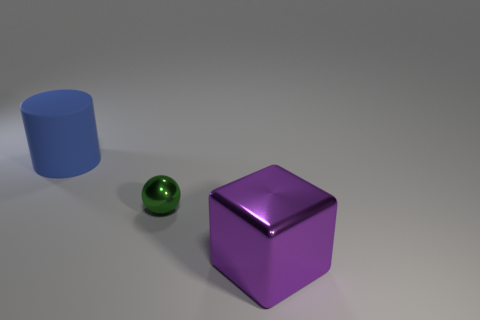What number of things are either large blue cylinders or small yellow matte blocks?
Offer a very short reply. 1. There is a blue thing; is it the same size as the shiny thing that is right of the small object?
Your response must be concise. Yes. How many other things are made of the same material as the purple cube?
Provide a succinct answer. 1. What number of objects are either big objects in front of the tiny object or things behind the large metal object?
Offer a terse response. 3. Is there a big blue cylinder?
Give a very brief answer. Yes. There is a thing that is behind the large metallic object and right of the blue thing; how big is it?
Give a very brief answer. Small. What is the shape of the tiny green thing?
Provide a succinct answer. Sphere. There is a large thing in front of the large blue thing; is there a large purple shiny block that is in front of it?
Offer a very short reply. No. There is a purple block that is the same size as the blue rubber cylinder; what material is it?
Your response must be concise. Metal. Are there any red metallic cylinders of the same size as the blue cylinder?
Your answer should be very brief. No. 